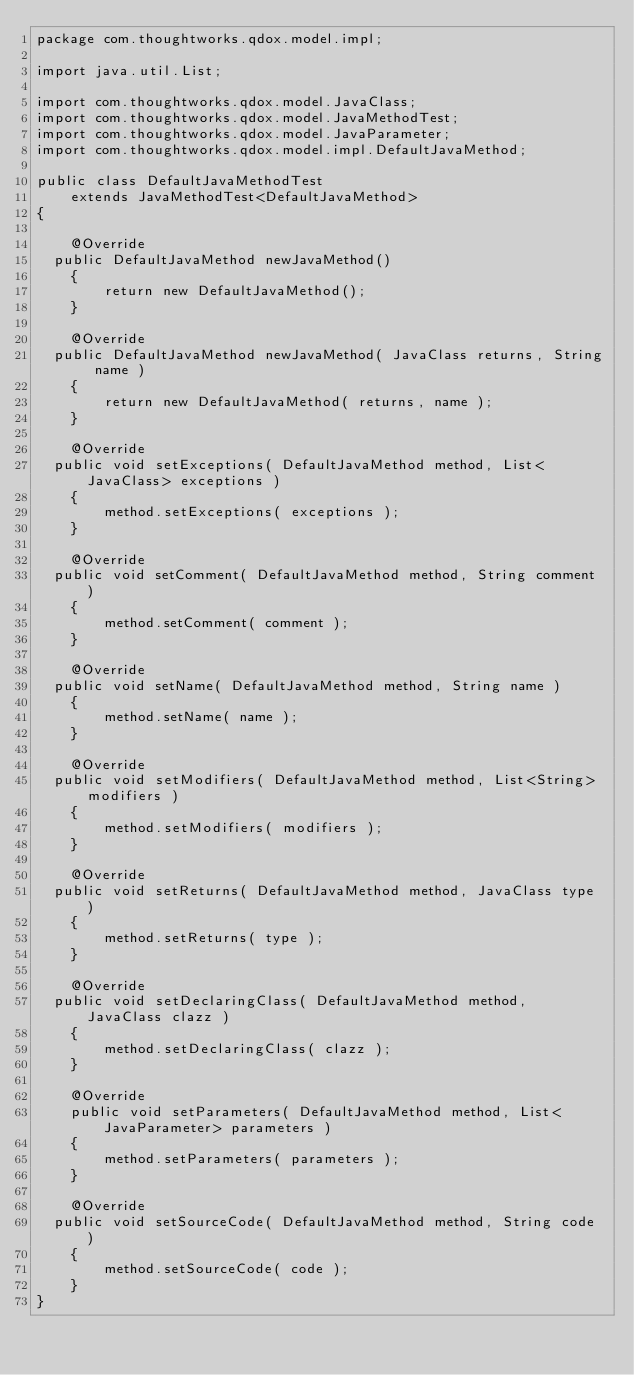<code> <loc_0><loc_0><loc_500><loc_500><_Java_>package com.thoughtworks.qdox.model.impl;

import java.util.List;

import com.thoughtworks.qdox.model.JavaClass;
import com.thoughtworks.qdox.model.JavaMethodTest;
import com.thoughtworks.qdox.model.JavaParameter;
import com.thoughtworks.qdox.model.impl.DefaultJavaMethod;

public class DefaultJavaMethodTest
    extends JavaMethodTest<DefaultJavaMethod>
{

    @Override
	public DefaultJavaMethod newJavaMethod()
    {
        return new DefaultJavaMethod();
    }

    @Override
	public DefaultJavaMethod newJavaMethod( JavaClass returns, String name )
    {
        return new DefaultJavaMethod( returns, name );
    }

    @Override
	public void setExceptions( DefaultJavaMethod method, List<JavaClass> exceptions )
    {
        method.setExceptions( exceptions );
    }

    @Override
	public void setComment( DefaultJavaMethod method, String comment )
    {
        method.setComment( comment );
    }

    @Override
	public void setName( DefaultJavaMethod method, String name )
    {
        method.setName( name );
    }

    @Override
	public void setModifiers( DefaultJavaMethod method, List<String> modifiers )
    {
        method.setModifiers( modifiers );
    }

    @Override
	public void setReturns( DefaultJavaMethod method, JavaClass type )
    {
        method.setReturns( type );
    }

    @Override
	public void setDeclaringClass( DefaultJavaMethod method, JavaClass clazz )
    {
        method.setDeclaringClass( clazz );
    }

    @Override
    public void setParameters( DefaultJavaMethod method, List<JavaParameter> parameters )
    {
        method.setParameters( parameters );
    }

    @Override
	public void setSourceCode( DefaultJavaMethod method, String code )
    {
        method.setSourceCode( code );
    }
}
</code> 